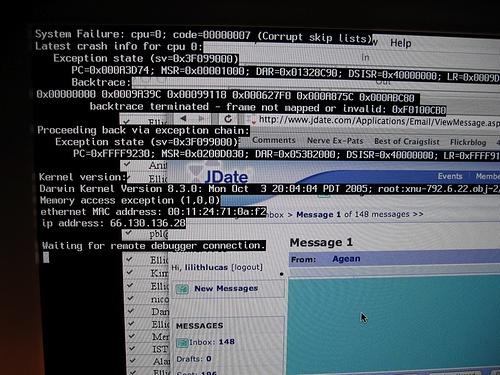Describe the objects in this image and their specific colors. I can see a laptop in black, darkgray, gray, and teal tones in this image. 